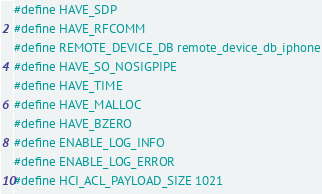<code> <loc_0><loc_0><loc_500><loc_500><_C_>#define HAVE_SDP
#define HAVE_RFCOMM
#define REMOTE_DEVICE_DB remote_device_db_iphone
#define HAVE_SO_NOSIGPIPE
#define HAVE_TIME
#define HAVE_MALLOC
#define HAVE_BZERO
#define ENABLE_LOG_INFO 
#define ENABLE_LOG_ERROR
#define HCI_ACL_PAYLOAD_SIZE 1021
</code> 